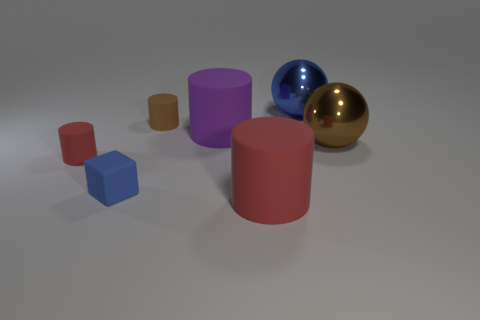Subtract 1 cylinders. How many cylinders are left? 3 Subtract all blue cylinders. Subtract all cyan cubes. How many cylinders are left? 4 Add 2 tiny red metallic spheres. How many objects exist? 9 Subtract all cubes. How many objects are left? 6 Subtract 0 yellow balls. How many objects are left? 7 Subtract all brown rubber balls. Subtract all large purple objects. How many objects are left? 6 Add 3 tiny brown matte cylinders. How many tiny brown matte cylinders are left? 4 Add 4 big red objects. How many big red objects exist? 5 